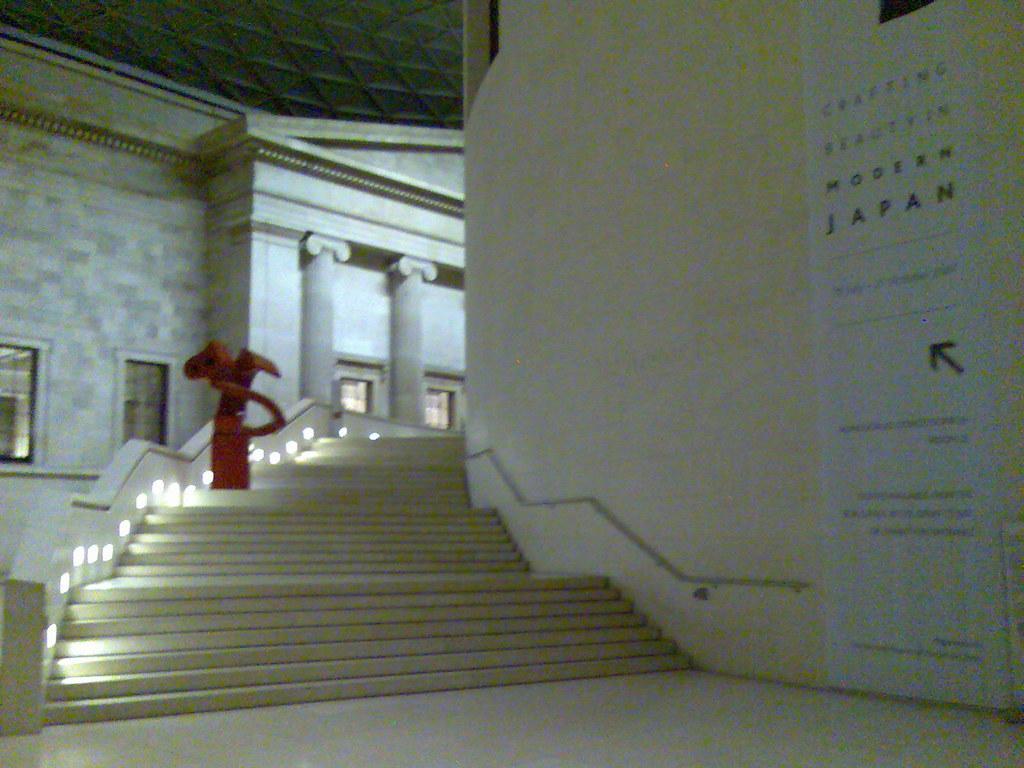How would you summarize this image in a sentence or two? This is a staircase which is in white color there are lights on it. 